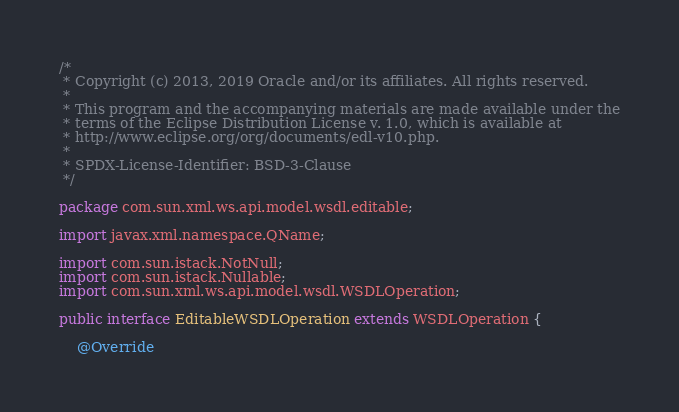<code> <loc_0><loc_0><loc_500><loc_500><_Java_>/*
 * Copyright (c) 2013, 2019 Oracle and/or its affiliates. All rights reserved.
 *
 * This program and the accompanying materials are made available under the
 * terms of the Eclipse Distribution License v. 1.0, which is available at
 * http://www.eclipse.org/org/documents/edl-v10.php.
 *
 * SPDX-License-Identifier: BSD-3-Clause
 */

package com.sun.xml.ws.api.model.wsdl.editable;

import javax.xml.namespace.QName;

import com.sun.istack.NotNull;
import com.sun.istack.Nullable;
import com.sun.xml.ws.api.model.wsdl.WSDLOperation;

public interface EditableWSDLOperation extends WSDLOperation {

    @Override</code> 